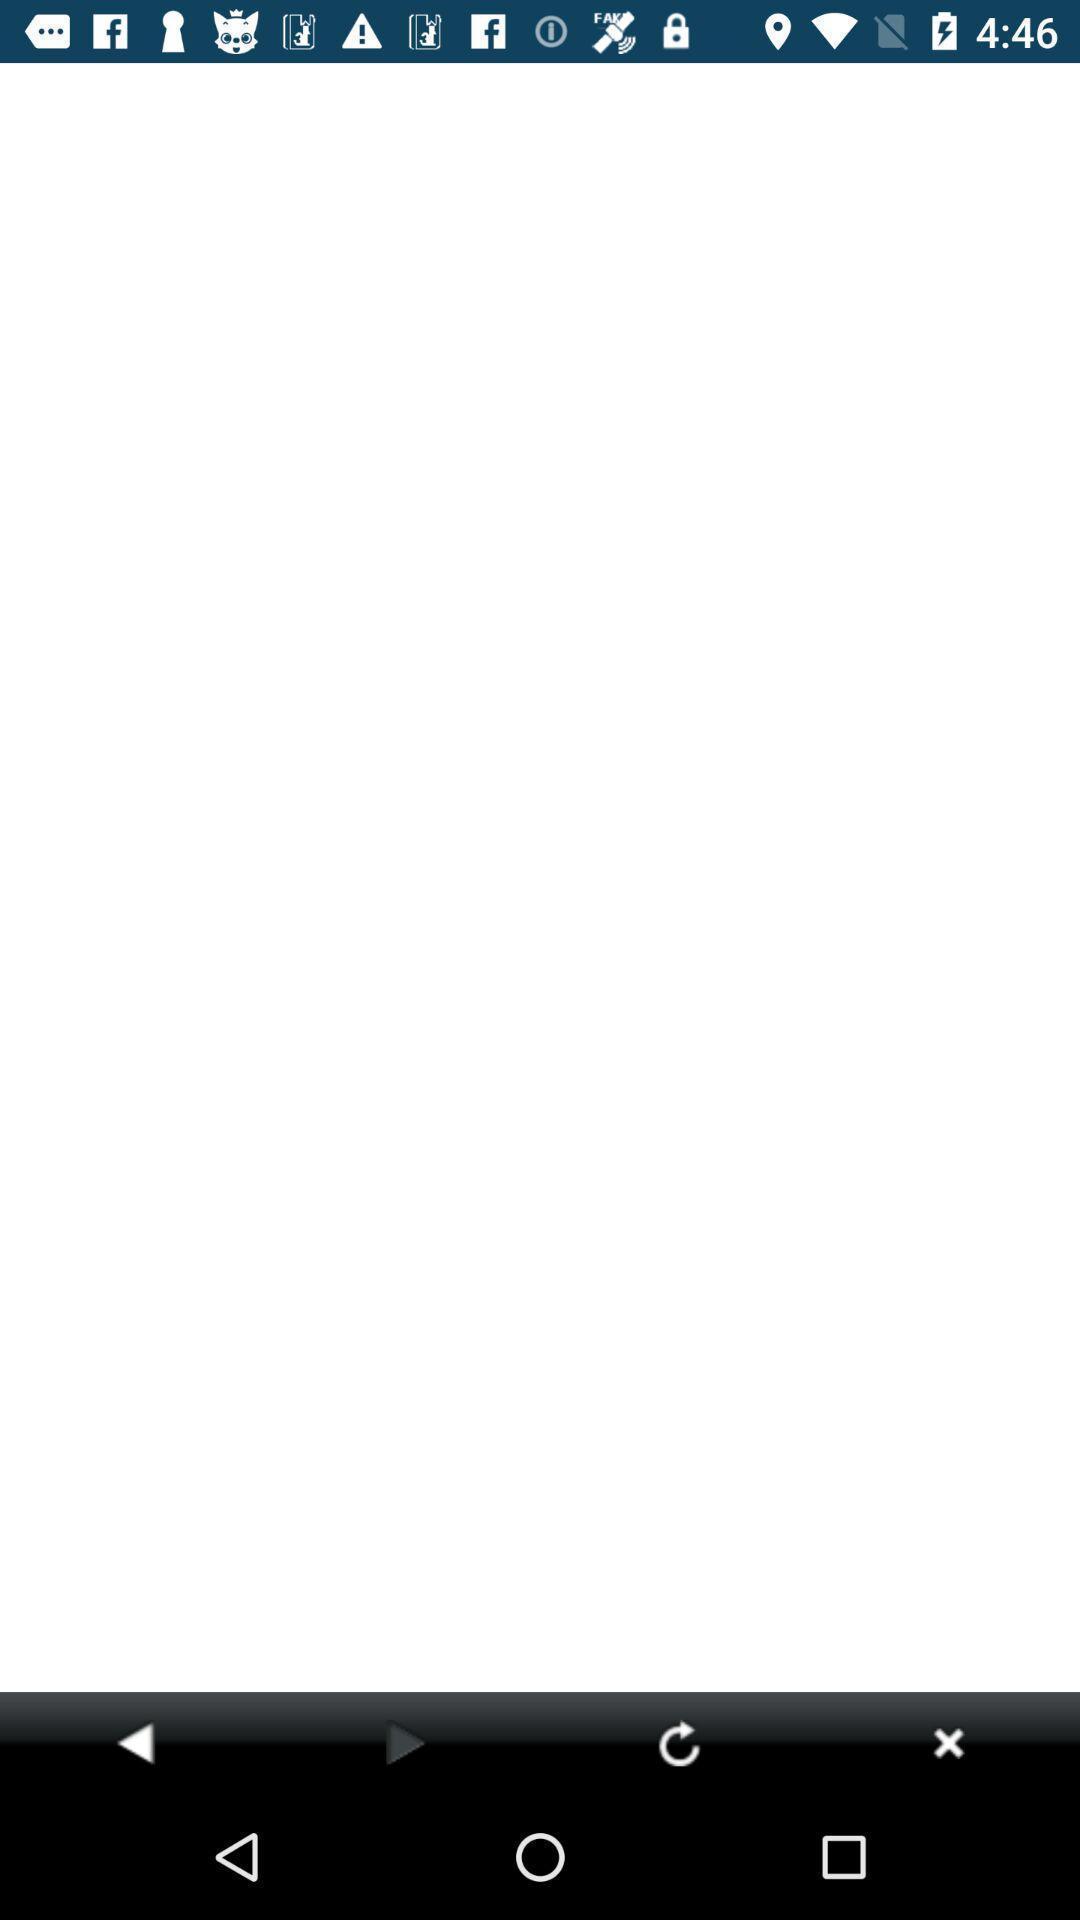Describe this image in words. Window displaying a gas app. 